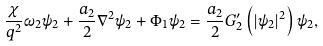<formula> <loc_0><loc_0><loc_500><loc_500>\frac { \chi } { q ^ { 2 } } \omega _ { 2 } \psi _ { 2 } + \frac { a _ { 2 } } { 2 } \nabla ^ { 2 } \psi _ { 2 } + \Phi _ { 1 } \psi _ { 2 } = \frac { a _ { 2 } } { 2 } G _ { 2 } ^ { \prime } \left ( \left | \psi _ { 2 } \right | ^ { 2 } \right ) \psi _ { 2 } ,</formula> 